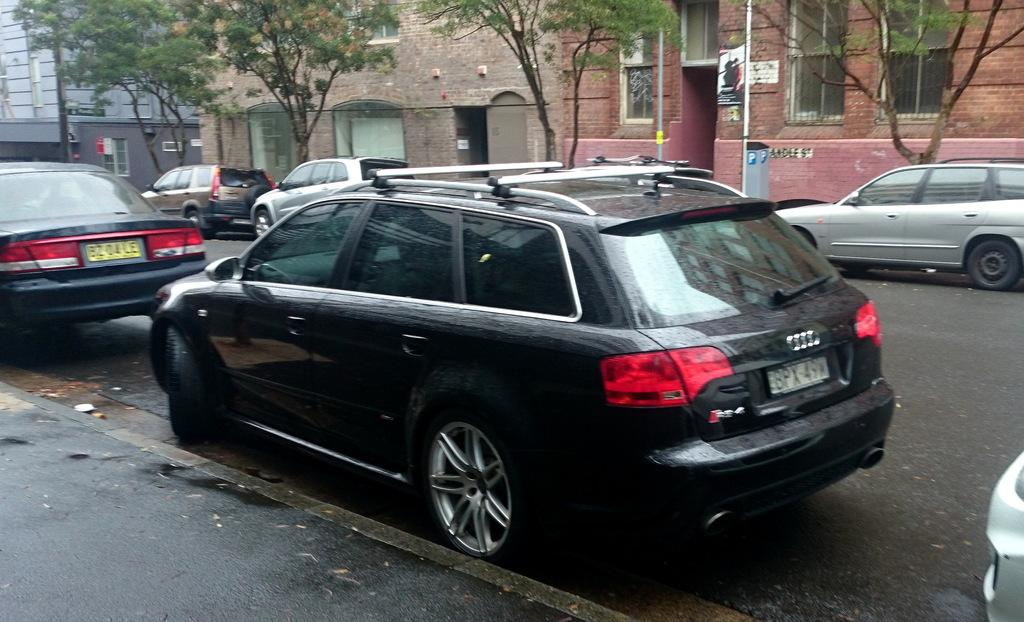What type of vehicles can be seen on the road in the image? There are cars on the road in the image. What can be seen in the distance behind the cars? There are buildings, poles, and trees in the background of the image. What flavor of ice cream is being served at the arm of the building in the image? There is no ice cream or arm of a building present in the image. 